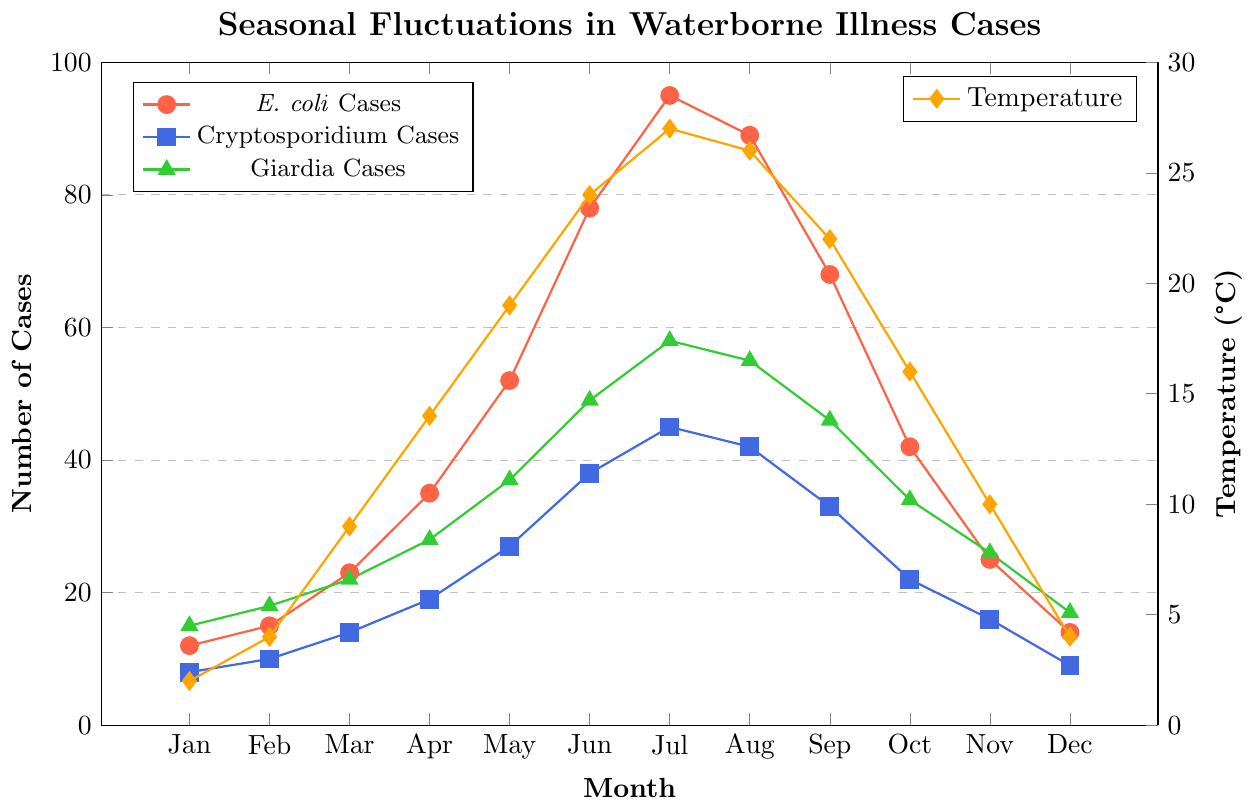What month has the highest number of E. coli cases? Look at the E. coli line (red) and identify the highest point on the y-axis. The peak is in July.
Answer: July Compare the number of Giardia cases in January and August. Which month has more cases? Observe the green line representing Giardia cases. In January, there are 15 cases; in August, there are 55 cases. August has more cases.
Answer: August What is the average number of Cryptosporidium cases reported in the first quarter (January to March)? Add the cases from January (8), February (10), and March (14), then divide by 3. (8 + 10 + 14) / 3 = 32 / 3 = 10.67
Answer: 10.67 How does the temperature in September compare to July? Check the orange line for temperatures for both months. In July, the temperature is 27°C; in September, it is 22°C. July is warmer than September.
Answer: July is warmer Are there more E. coli cases or Cryptosporidium cases in April? Compare the respective points on the red and blue lines for April. There are 35 E. coli cases and 19 Cryptosporidium cases. E. coli has more cases.
Answer: E. coli What is the difference in the number of Giardia cases between June and November? Identify the points for June (49) and November (26) on the green line and subtract the two values. 49 - 26 = 23.
Answer: 23 What month has the lowest temperature and how many Cryptosporidium cases were reported that month? Locate the lowest point on the orange line (temperature) which is 2°C in January. Then, check the blue line for the number of Cryptosporidium cases in January, which is 8.
Answer: January, 8 What is the trend of E. coli cases from January to July? Observe the red line's direction from January to July. It shows an increasing trend, reaching from 12 cases in January to 95 cases in July.
Answer: Increasing trend Calculate the total number of Giardia cases reported over the year. Sum the values of the green line for each month: 15 + 18 + 22 + 28 + 37 + 49 + 58 + 55 + 46 + 34 + 26 + 17 = 405.
Answer: 405 In which months do the E. coli cases start to decrease following their peak, and by how much do they decrease from the peak month to December? Identify the peak in July with 95 cases, then observe the decrease in subsequent months: August (89), September (68), October (42), November (25), December (14). The decrease from July to December is 95 - 14 = 81.
Answer: August to December, 81 